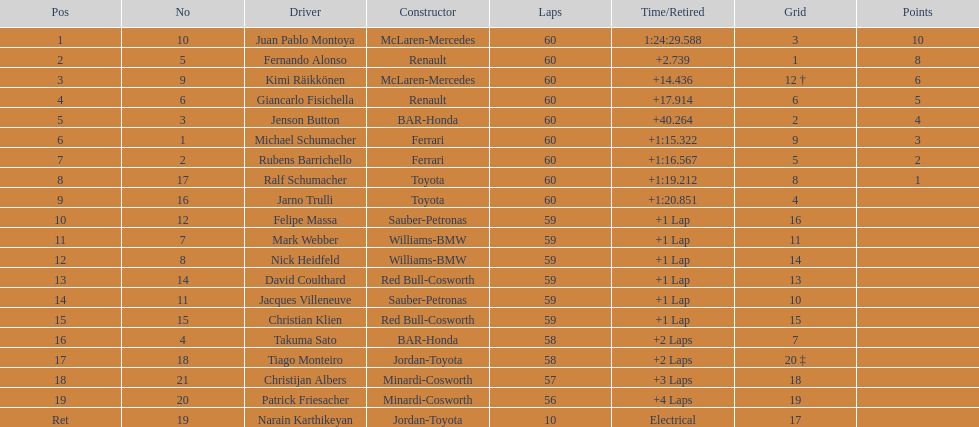How many toyota's are there on the list? 4. 